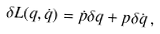Convert formula to latex. <formula><loc_0><loc_0><loc_500><loc_500>\delta L ( q , \dot { q } ) = \dot { p } \delta q + p \delta \dot { q } \, ,</formula> 